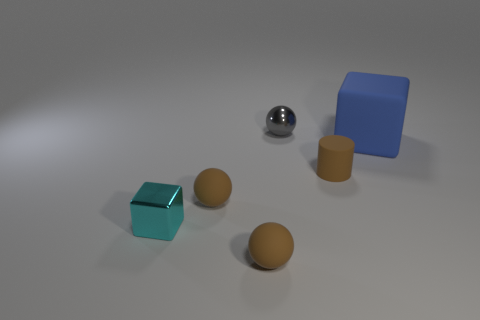Are there any other things that have the same size as the blue rubber block?
Keep it short and to the point. No. There is a cylinder; does it have the same size as the object behind the big blue thing?
Give a very brief answer. Yes. What color is the metal object that is behind the blue matte object?
Provide a short and direct response. Gray. What number of brown things are either big matte blocks or small balls?
Your answer should be very brief. 2. The rubber cube has what color?
Ensure brevity in your answer.  Blue. Are there fewer tiny matte balls on the right side of the tiny metal sphere than metal things that are on the right side of the cyan metallic thing?
Provide a succinct answer. Yes. What shape is the rubber thing that is behind the tiny cyan shiny object and in front of the rubber cylinder?
Provide a short and direct response. Sphere. What number of blue objects have the same shape as the cyan metal object?
Provide a short and direct response. 1. The brown cylinder that is made of the same material as the large blue block is what size?
Your answer should be very brief. Small. What number of yellow rubber spheres are the same size as the gray metal thing?
Your answer should be compact. 0. 